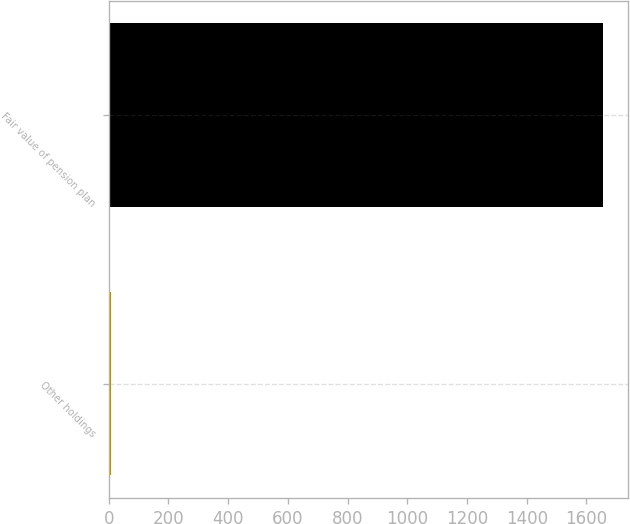Convert chart to OTSL. <chart><loc_0><loc_0><loc_500><loc_500><bar_chart><fcel>Other holdings<fcel>Fair value of pension plan<nl><fcel>8<fcel>1655<nl></chart> 